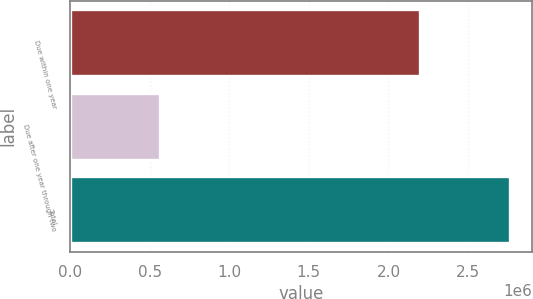Convert chart. <chart><loc_0><loc_0><loc_500><loc_500><bar_chart><fcel>Due within one year<fcel>Due after one year through two<fcel>Total<nl><fcel>2.20119e+06<fcel>563500<fcel>2.76469e+06<nl></chart> 